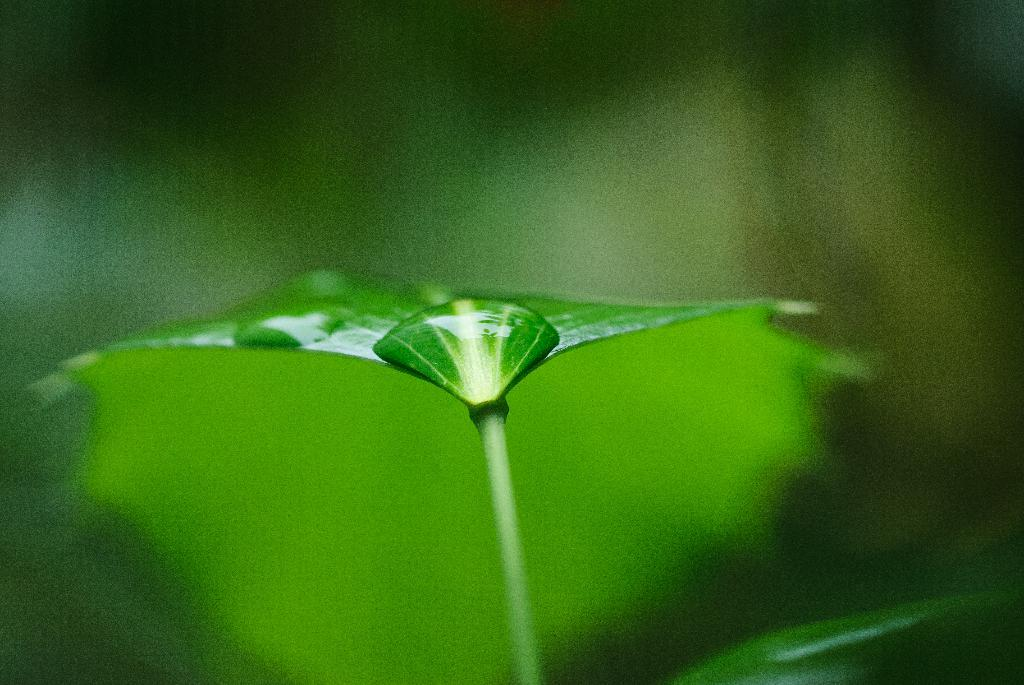What is the primary object in the image? There is a green leaf in the image. What is the condition of the leaf? The leaf has water drops on it. How would you describe the background of the image? The background of the image is blurred. What type of cup is being used to provide shade for the leaf in the image? There is no cup or shade present in the image; it only features a green leaf with water drops and a blurred background. 